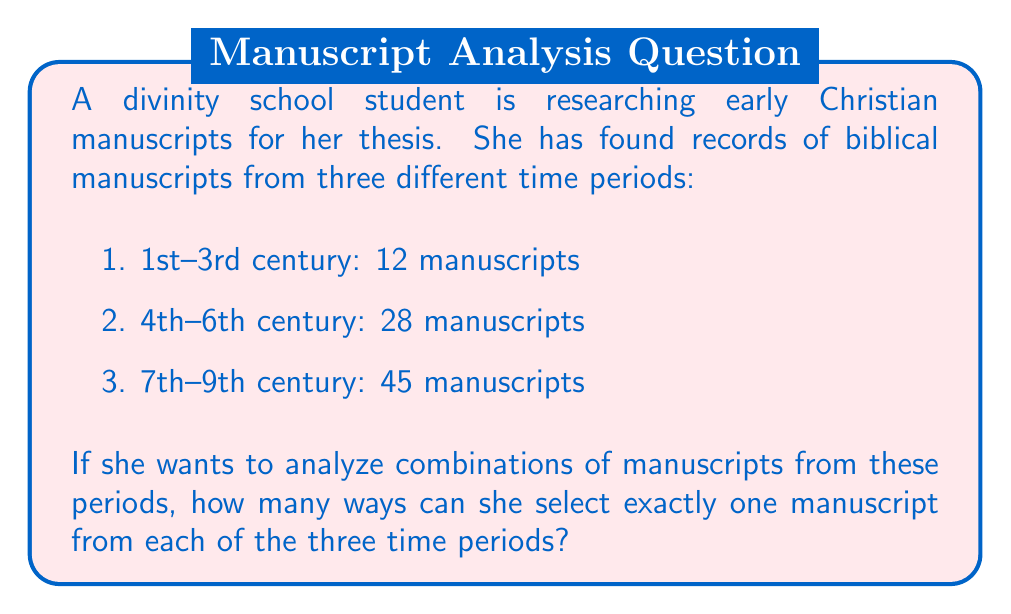Give your solution to this math problem. To solve this problem, we need to use the multiplication principle of counting. This principle states that if we have a sequence of independent choices, where there are $m$ ways of making the first choice, $n$ ways of making the second choice, and $p$ ways of making the third choice, then there are $m \times n \times p$ ways to make the sequence of choices.

In this case:
1. For the 1st-3rd century, there are 12 manuscripts to choose from.
2. For the 4th-6th century, there are 28 manuscripts to choose from.
3. For the 7th-9th century, there are 45 manuscripts to choose from.

Therefore, the total number of ways to select one manuscript from each time period is:

$$ 12 \times 28 \times 45 $$

Calculating this:
$$ 12 \times 28 = 336 $$
$$ 336 \times 45 = 15,120 $$

This means there are 15,120 different combinations of manuscripts that can be selected, with one from each time period.
Answer: 15,120 ways 